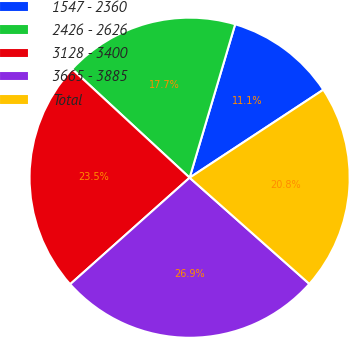Convert chart. <chart><loc_0><loc_0><loc_500><loc_500><pie_chart><fcel>1547 - 2360<fcel>2426 - 2626<fcel>3128 - 3400<fcel>3665 - 3885<fcel>Total<nl><fcel>11.14%<fcel>17.71%<fcel>23.47%<fcel>26.86%<fcel>20.81%<nl></chart> 